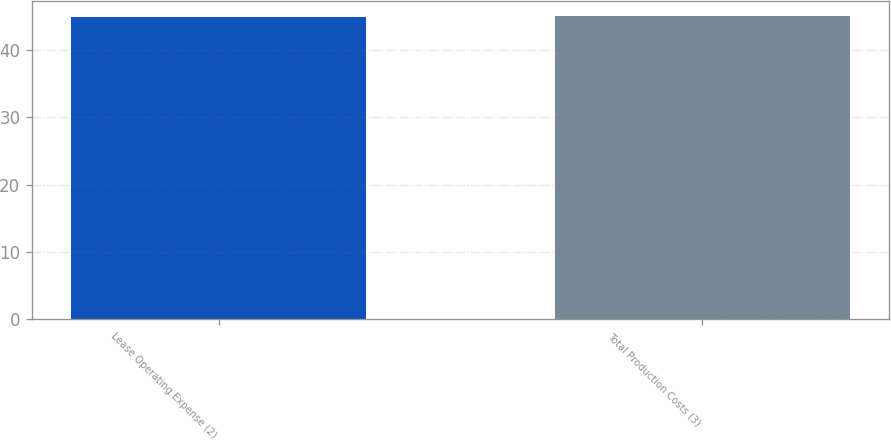Convert chart to OTSL. <chart><loc_0><loc_0><loc_500><loc_500><bar_chart><fcel>Lease Operating Expense (2)<fcel>Total Production Costs (3)<nl><fcel>45<fcel>45.1<nl></chart> 